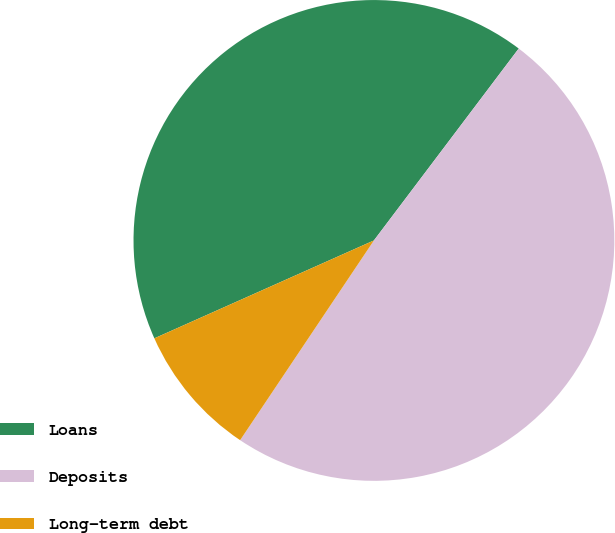<chart> <loc_0><loc_0><loc_500><loc_500><pie_chart><fcel>Loans<fcel>Deposits<fcel>Long-term debt<nl><fcel>41.96%<fcel>49.1%<fcel>8.93%<nl></chart> 